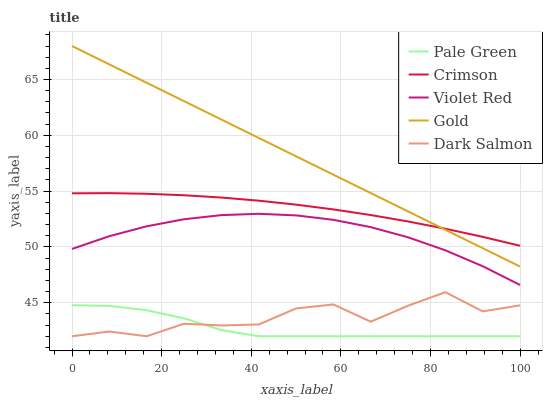Does Pale Green have the minimum area under the curve?
Answer yes or no. Yes. Does Gold have the maximum area under the curve?
Answer yes or no. Yes. Does Violet Red have the minimum area under the curve?
Answer yes or no. No. Does Violet Red have the maximum area under the curve?
Answer yes or no. No. Is Gold the smoothest?
Answer yes or no. Yes. Is Dark Salmon the roughest?
Answer yes or no. Yes. Is Violet Red the smoothest?
Answer yes or no. No. Is Violet Red the roughest?
Answer yes or no. No. Does Pale Green have the lowest value?
Answer yes or no. Yes. Does Violet Red have the lowest value?
Answer yes or no. No. Does Gold have the highest value?
Answer yes or no. Yes. Does Violet Red have the highest value?
Answer yes or no. No. Is Pale Green less than Crimson?
Answer yes or no. Yes. Is Gold greater than Pale Green?
Answer yes or no. Yes. Does Crimson intersect Gold?
Answer yes or no. Yes. Is Crimson less than Gold?
Answer yes or no. No. Is Crimson greater than Gold?
Answer yes or no. No. Does Pale Green intersect Crimson?
Answer yes or no. No. 